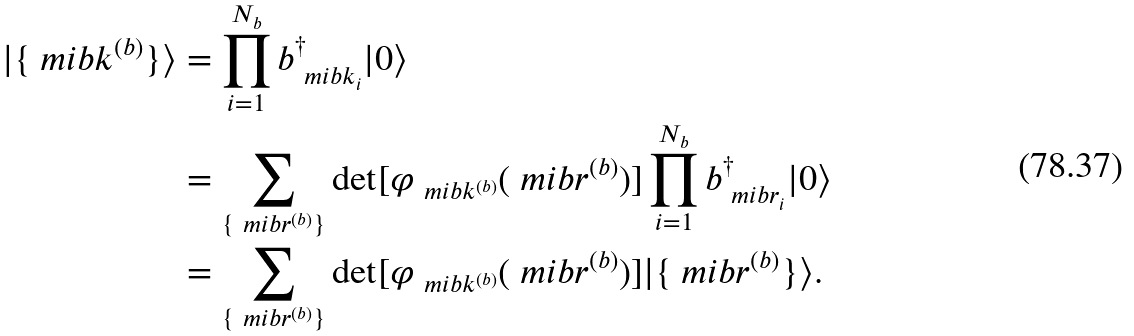Convert formula to latex. <formula><loc_0><loc_0><loc_500><loc_500>| \{ \ m i b { k } ^ { ( b ) } \} \rangle & = \prod ^ { N _ { b } } _ { i = 1 } b ^ { \dagger } _ { \ m i b { k } _ { i } } | 0 \rangle \\ & = \sum _ { \{ \ m i b { r } ^ { ( b ) } \} } \det [ \varphi _ { \ m i b { k } ^ { ( b ) } } ( \ m i b { r } ^ { ( b ) } ) ] \prod ^ { N _ { b } } _ { i = 1 } b ^ { \dagger } _ { \ m i b { r } _ { i } } | 0 \rangle \\ & = \sum _ { \{ \ m i b { r } ^ { ( b ) } \} } \det [ \varphi _ { \ m i b { k } ^ { ( b ) } } ( \ m i b { r } ^ { ( b ) } ) ] | \{ \ m i b { r } ^ { ( b ) } \} \rangle .</formula> 